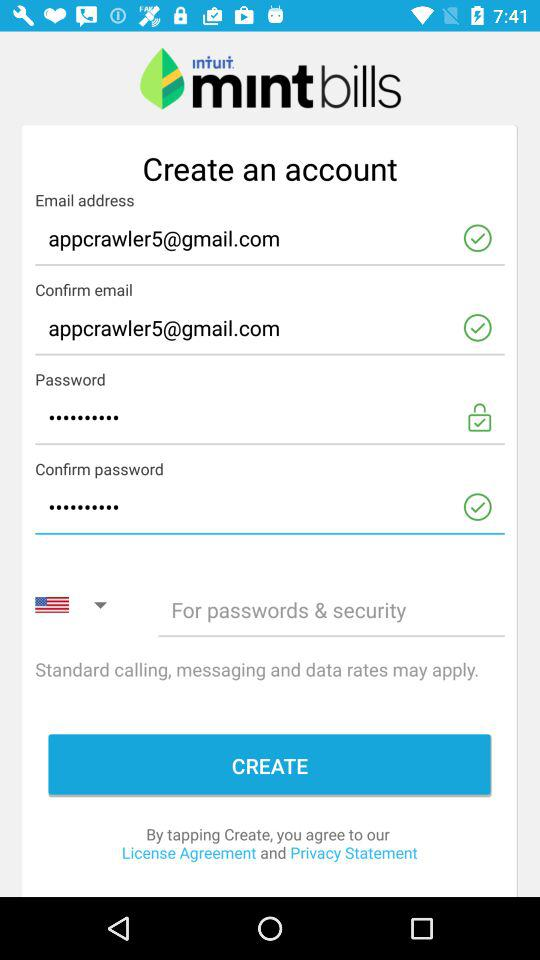What is the email address? The email address is appcrawler5@gmail.com. 